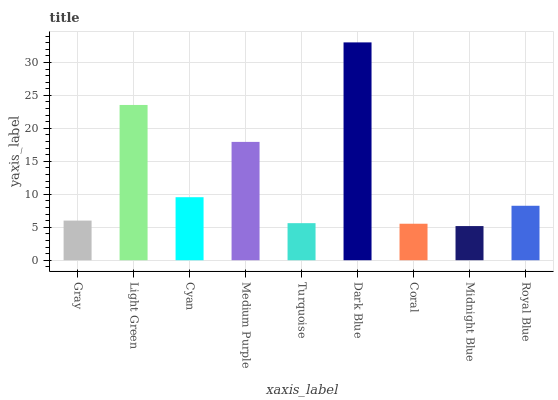Is Midnight Blue the minimum?
Answer yes or no. Yes. Is Dark Blue the maximum?
Answer yes or no. Yes. Is Light Green the minimum?
Answer yes or no. No. Is Light Green the maximum?
Answer yes or no. No. Is Light Green greater than Gray?
Answer yes or no. Yes. Is Gray less than Light Green?
Answer yes or no. Yes. Is Gray greater than Light Green?
Answer yes or no. No. Is Light Green less than Gray?
Answer yes or no. No. Is Royal Blue the high median?
Answer yes or no. Yes. Is Royal Blue the low median?
Answer yes or no. Yes. Is Medium Purple the high median?
Answer yes or no. No. Is Gray the low median?
Answer yes or no. No. 